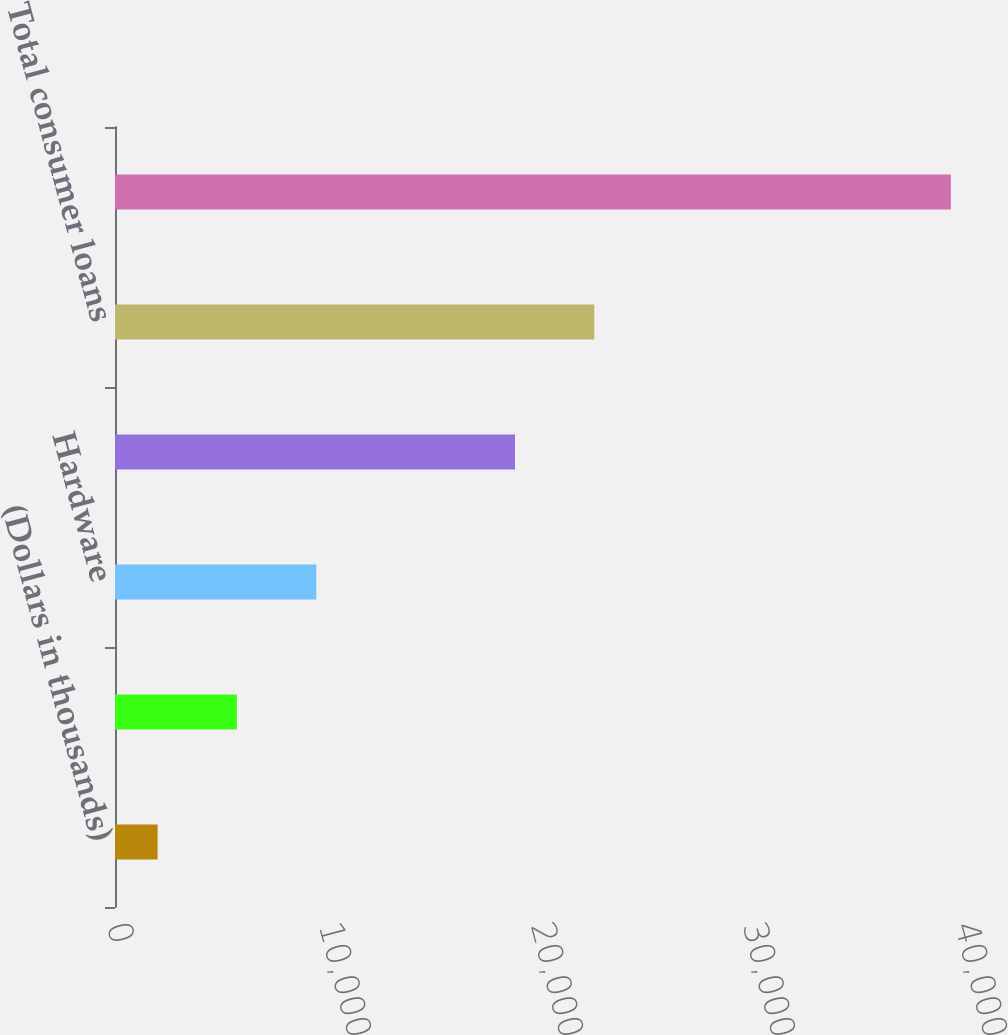Convert chart. <chart><loc_0><loc_0><loc_500><loc_500><bar_chart><fcel>(Dollars in thousands)<fcel>Software<fcel>Hardware<fcel>Total commercial loans<fcel>Total consumer loans<fcel>Total nonaccrual loans<nl><fcel>2010<fcel>5751.6<fcel>9493.2<fcel>18867<fcel>22608.6<fcel>39426<nl></chart> 